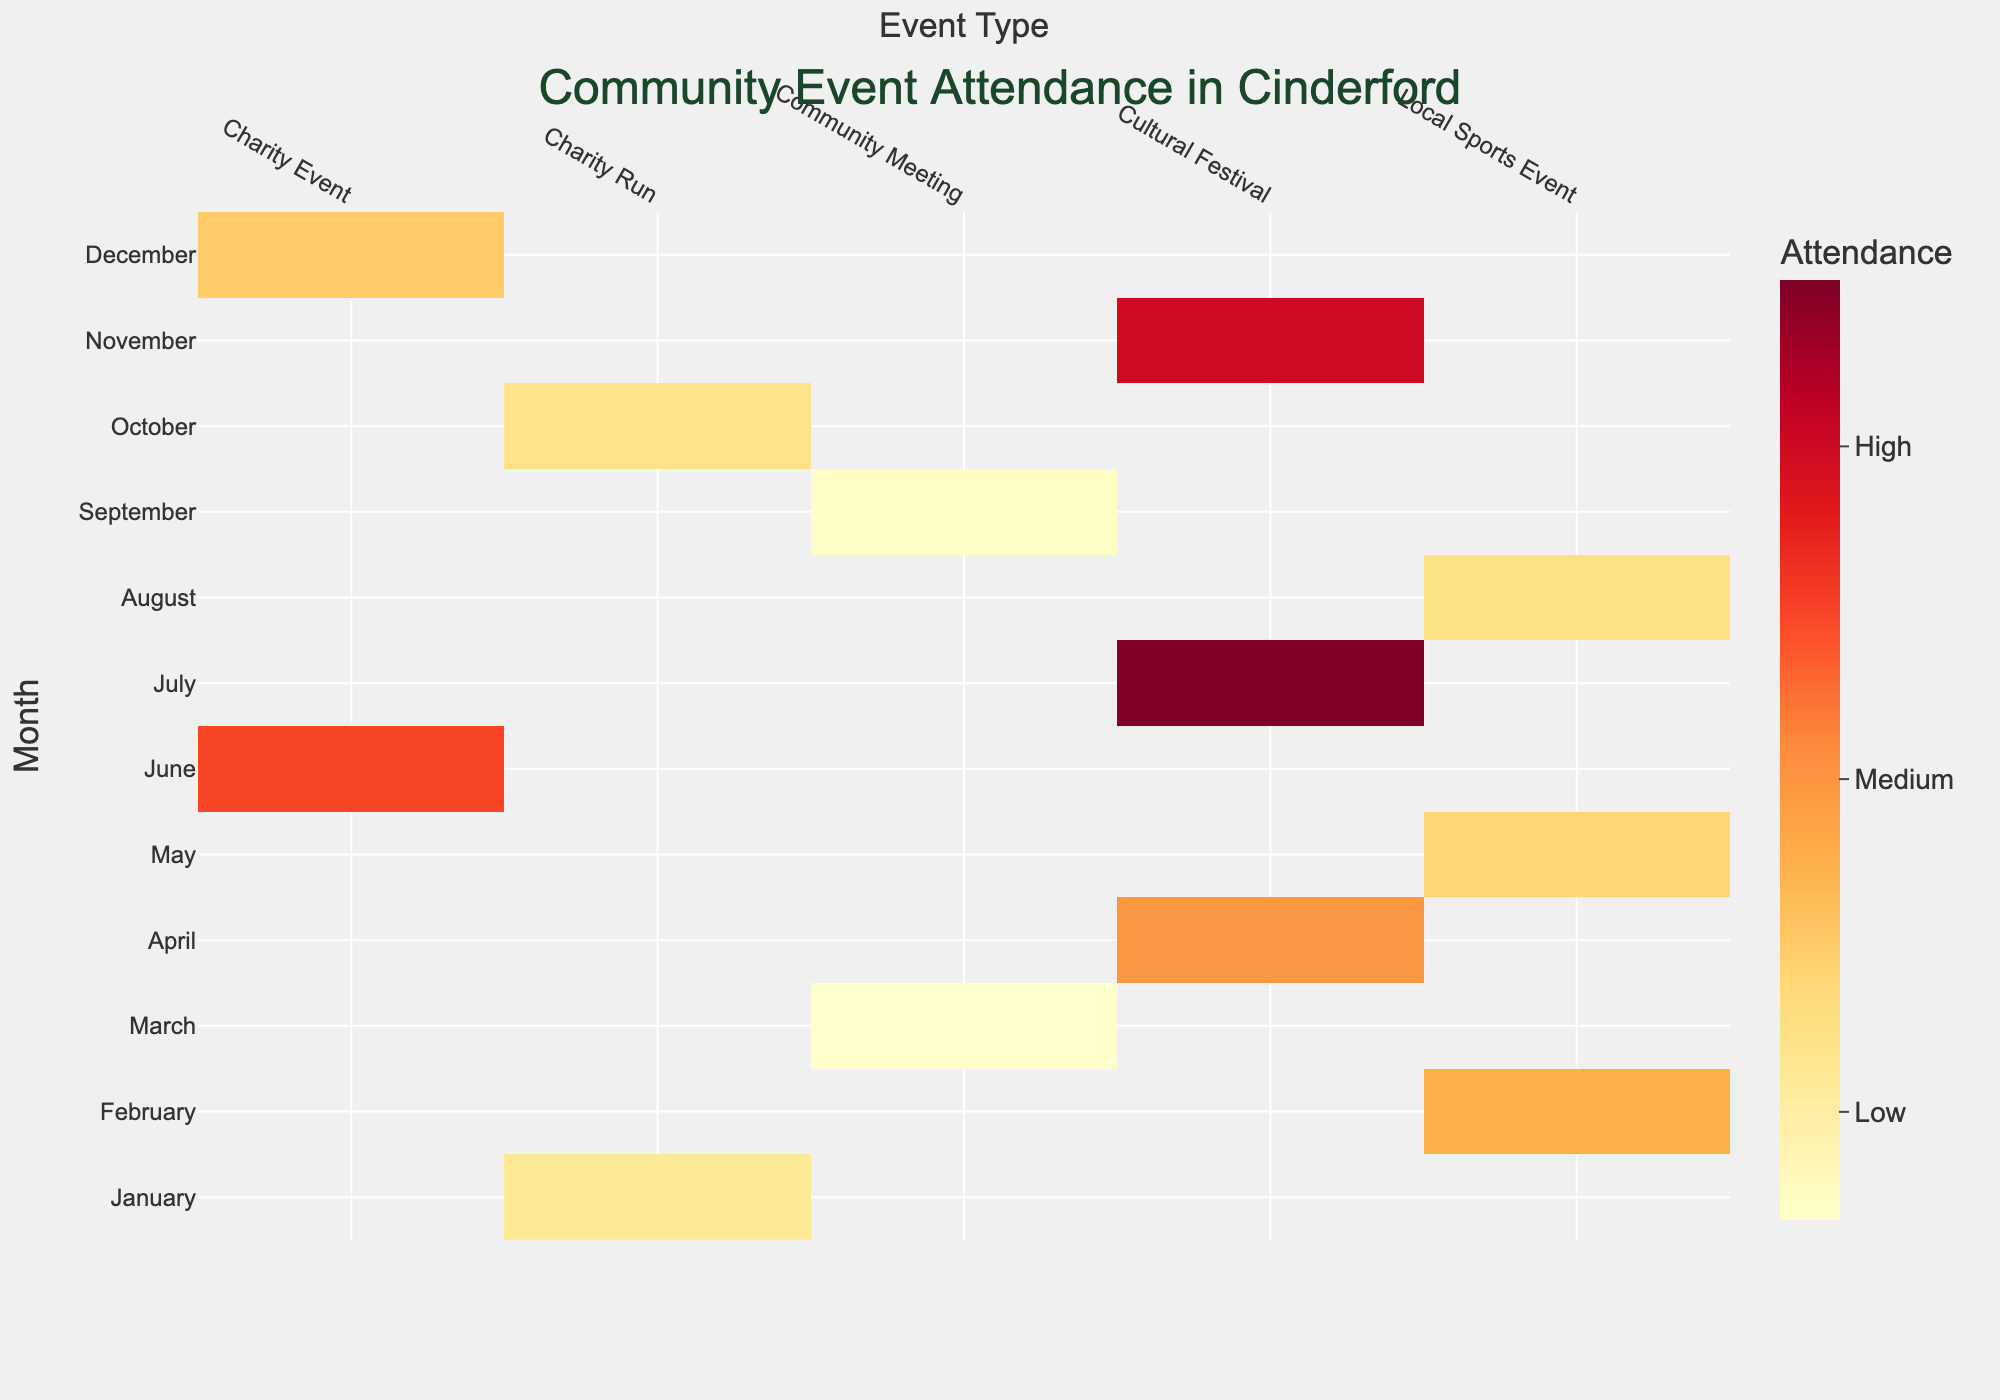What's the title of the heatmap? The title of the heatmap can be found at the top of the chart. The presented figure title is "Community Event Attendance in Cinderford".
Answer: Community Event Attendance in Cinderford Which month has the highest attendance for a charity event? Locate the "Charity Event" column on the heatmap. Then, find the highest attendance value within that column. June has an attendance of 400, which is the highest for a charity event.
Answer: June What's the attendance for the "Cinderford Cycling Marathon" event? Find the month of May on the y-axis, then look at the "Local Sports Event" column. The intersection gives the attendance figure of 180.
Answer: 180 Is the attendance for "Cinderford Day Celebration" higher or lower than the "Winter Warmth Run"? Locate July in the y-axis for the "Cinderford Day Celebration" and January for the "Winter Warmth Run". Compare the values from the heatmap. July has 600, and January has 120, so July's event has higher attendance.
Answer: Higher What is the average attendance for local sports events over the year? Identify the attendance figures for all local sports events: February (250), May (180), and August (150). Sum these values (250 + 180 + 150 = 580) and divide by 3 (580/3 ≈ 193.33).
Answer: Approximately 193.33 Which month has the lowest attendance for any type of event? Scan the heatmap to find the smallest attendance value. March has the lowest with 35 for "Community Meeting".
Answer: March How does the attendance in November compare to December for cultural festivals? Find November and December on the y-axis and compare the attendance in the "Cultural Festival" column. November has an attendance of 500, whereas December's column entry does not exist as it does not host a cultural festival.
Answer: November has cultural festival attendance, December does not What is the total attendance for all charity runs throughout the year? Identify and sum the attendance figures for charity runs in January (120) and October (140). The total is 120 + 140 = 260.
Answer: 260 Between Community Meetings and Cultural Festivals, which type has more events throughout the year? Count the number of unique months with events for Community Meetings and Cultural Festivals. Community Meetings are in March and September (2 events), Cultural Festivals in April, July, and November (3 events).
Answer: Cultural Festivals Are there any months where multiple event types occur? Locate any months with more than one color/value in the same row. No month has multiple event types.
Answer: No 